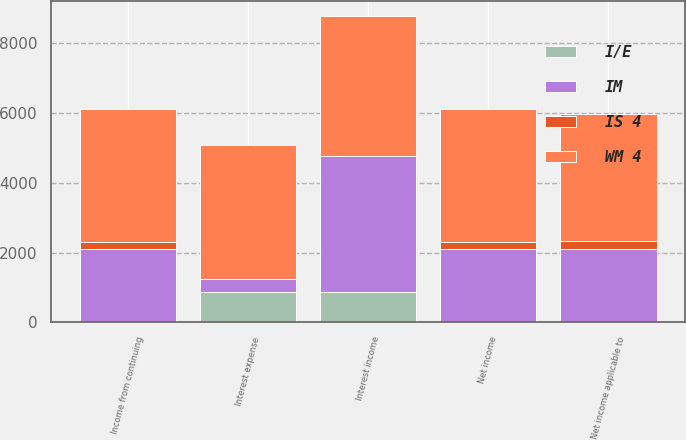Convert chart to OTSL. <chart><loc_0><loc_0><loc_500><loc_500><stacked_bar_chart><ecel><fcel>Interest income<fcel>Interest expense<fcel>Income from continuing<fcel>Net income<fcel>Net income applicable to<nl><fcel>WM 4<fcel>4005<fcel>3840<fcel>3805<fcel>3804<fcel>3649<nl><fcel>IM<fcel>3888<fcel>359<fcel>2104<fcel>2104<fcel>2104<nl><fcel>IS 4<fcel>5<fcel>1<fcel>212<fcel>214<fcel>225<nl><fcel>I/E<fcel>882<fcel>882<fcel>1<fcel>1<fcel>1<nl></chart> 